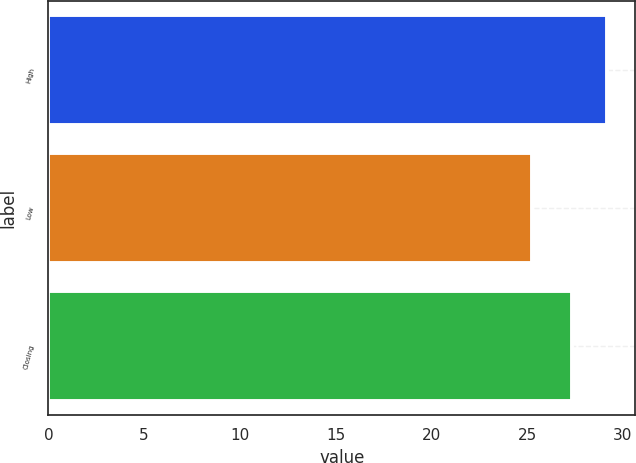Convert chart to OTSL. <chart><loc_0><loc_0><loc_500><loc_500><bar_chart><fcel>High<fcel>Low<fcel>Closing<nl><fcel>29.19<fcel>25.24<fcel>27.33<nl></chart> 